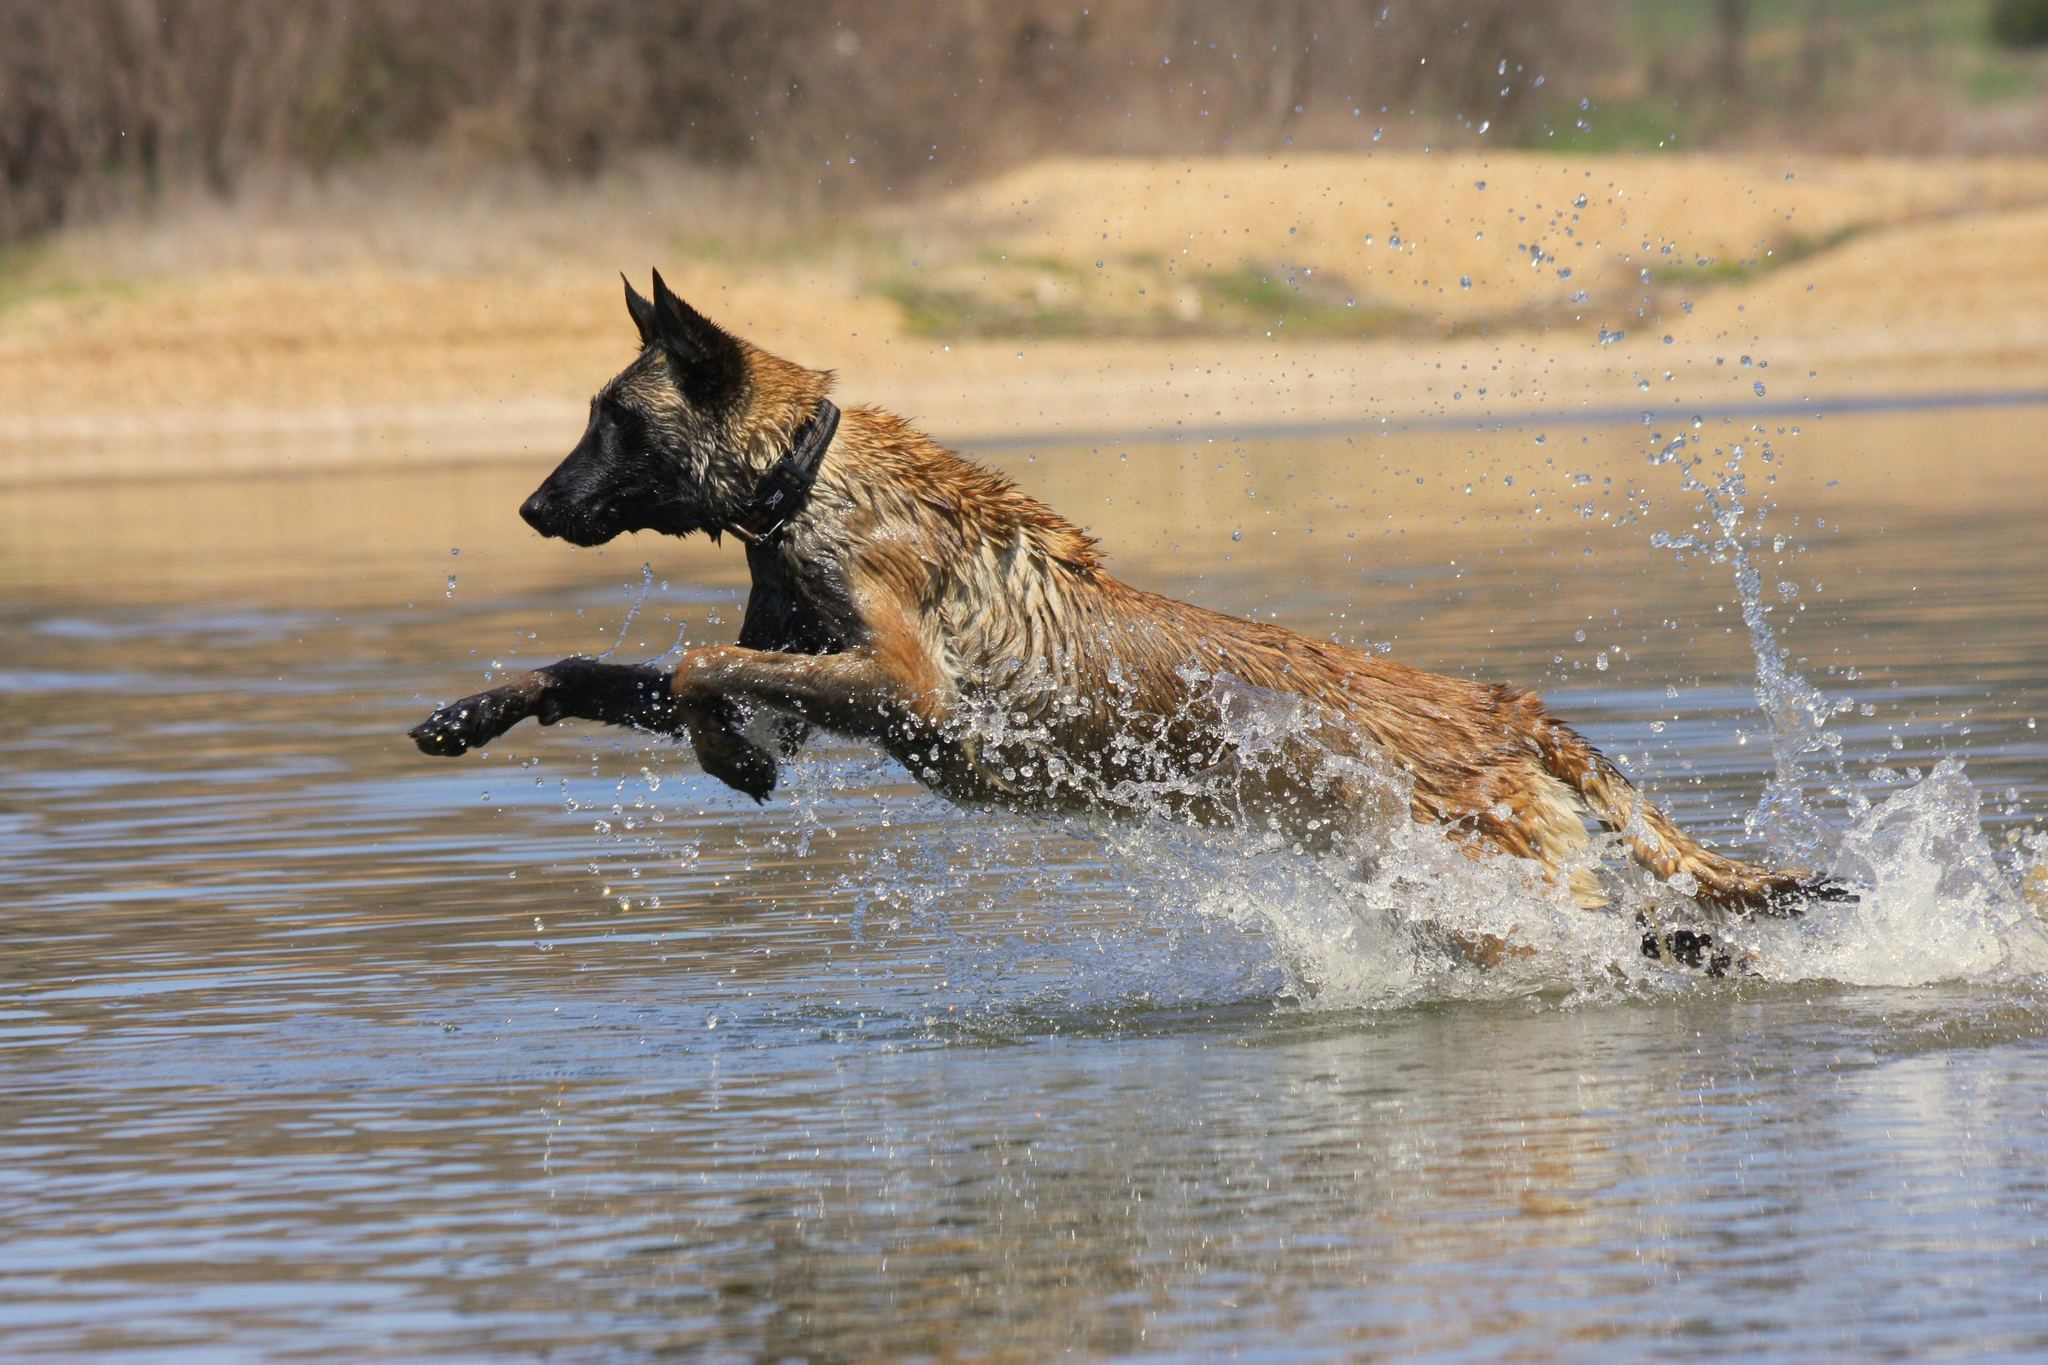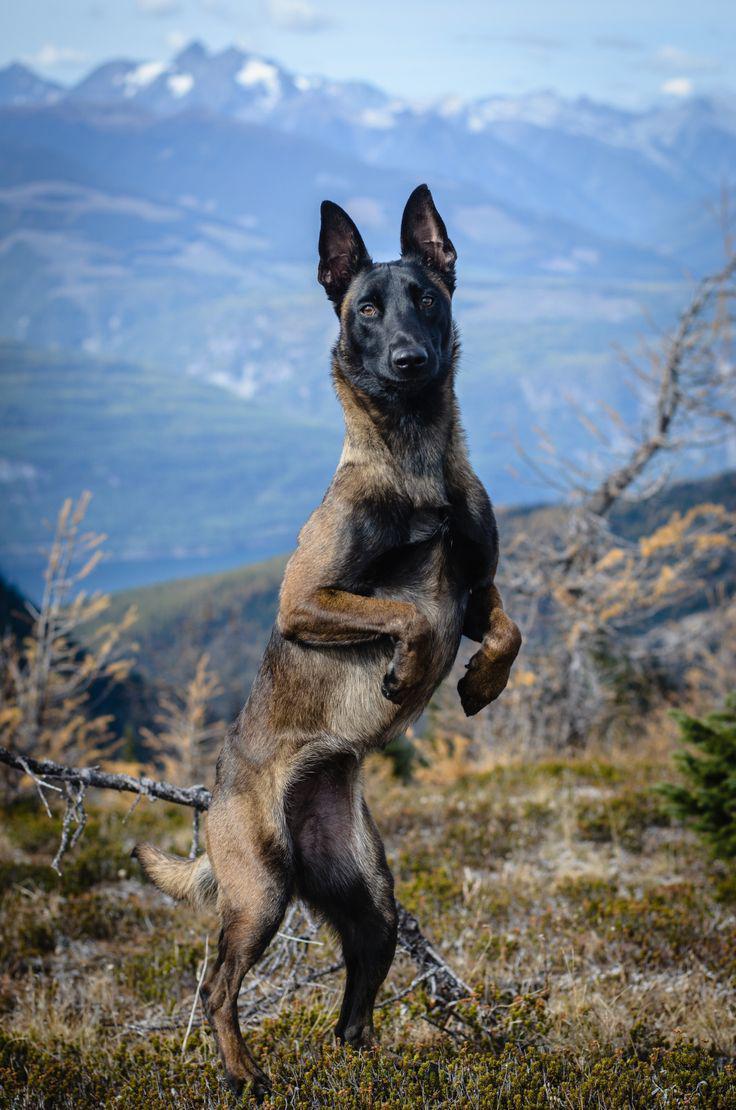The first image is the image on the left, the second image is the image on the right. For the images displayed, is the sentence "Two dogs are in water." factually correct? Answer yes or no. No. The first image is the image on the left, the second image is the image on the right. Assess this claim about the two images: "In one of the images there is a dog in the water in the center of the images.". Correct or not? Answer yes or no. Yes. 